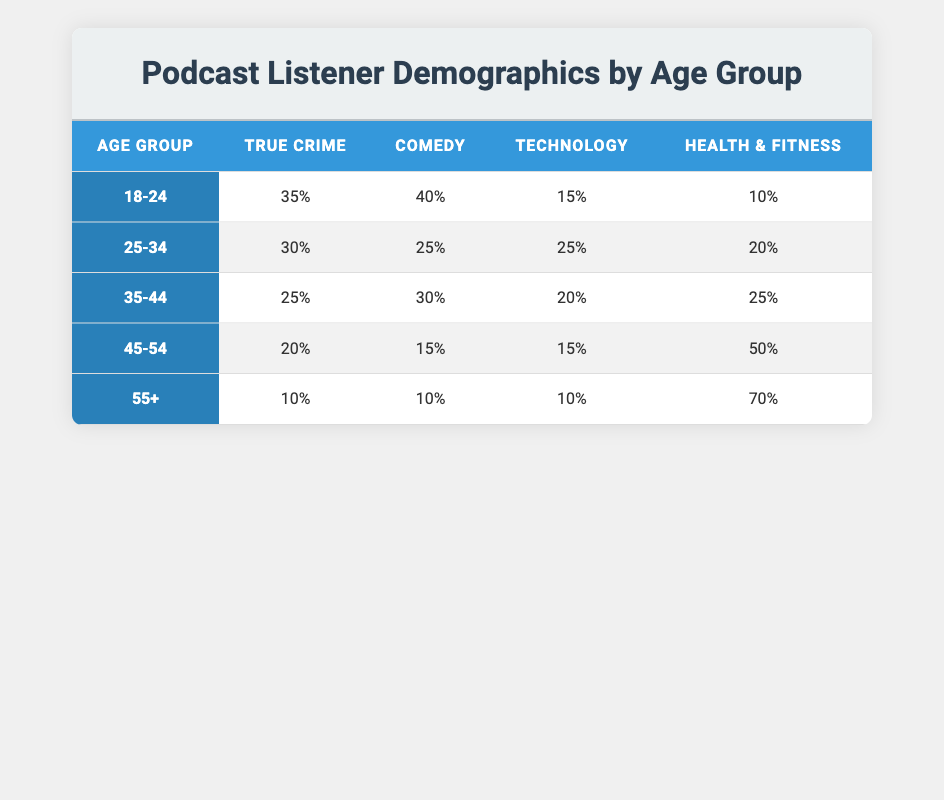What is the podcast preference for the 18-24 age group for Comedy? The table directly shows that for the 18-24 age group, the percentage of listeners who prefer Comedy is 40%.
Answer: 40% Which age group has the highest preference for Health & Fitness? Looking at the Health & Fitness column, the age group 55+ has the highest percentage at 70%.
Answer: 55+ What is the total percentage of True Crime listeners across all age groups? To find the total percentage of True Crime listeners, we add the values: 35 + 30 + 25 + 20 + 10 = 120.
Answer: 120 Is True Crime the most popular podcast genre among the 25-34 age group? By comparing the percentages for the 25-34 age group, True Crime at 30% is higher than Comedy at 25%, Technology at 25%, and Health & Fitness at 20%. Thus, True Crime is the most popular for this age group.
Answer: Yes What percentage of listeners aged 45-54 prefer Technology to those aged 35-44? From the table, the preference for Technology in the 45-54 age group is 15%, and for the 35-44 age group, it is 20%. To find the difference, calculate 20 - 15 = 5.
Answer: 5 Which age group has the least preference for True Crime, and what is the percentage? The least preference for True Crime is from the 55+ age group, which has a percentage of 10%.
Answer: 55+ age group, 10% What is the average percentage for Comedy across all age groups? To calculate the average percentage for Comedy, we sum the percentages: 40 + 25 + 30 + 15 + 10 = 120, then divide by the number of age groups, which is 5: 120 / 5 = 24.
Answer: 24 Which podcast genre has a decreasing trend from the 18-24 age group to the 55+ age group? By examining the percentages of genres for each age group, it's noted that True Crime shows a decreasing trend from 35% to 10%, while other genres either increase or fluctuate.
Answer: True Crime How many percentage points does the preference for Technology drop from 25-34 to 35-44 age groups? The preference for Technology in the 25-34 age group is 25%, and in the 35-44 age group it is 20%. The difference is calculated as 25 - 20 = 5 percentage points.
Answer: 5 